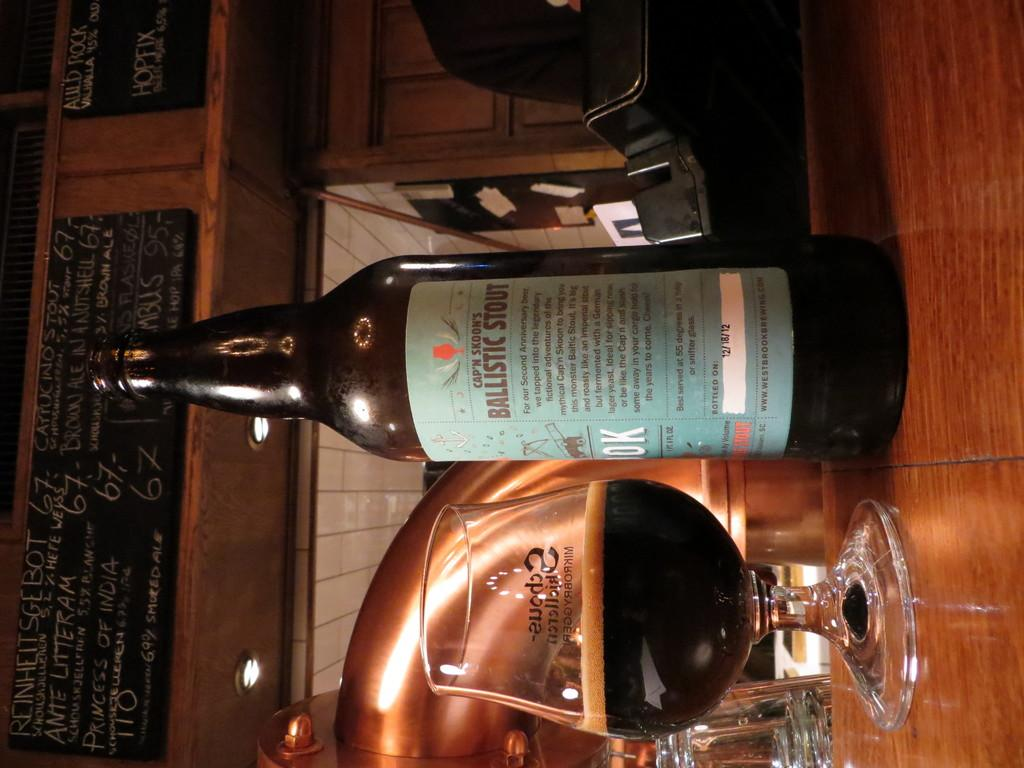<image>
Give a short and clear explanation of the subsequent image. The bottle of beer on the table is Ballistic Stout. 